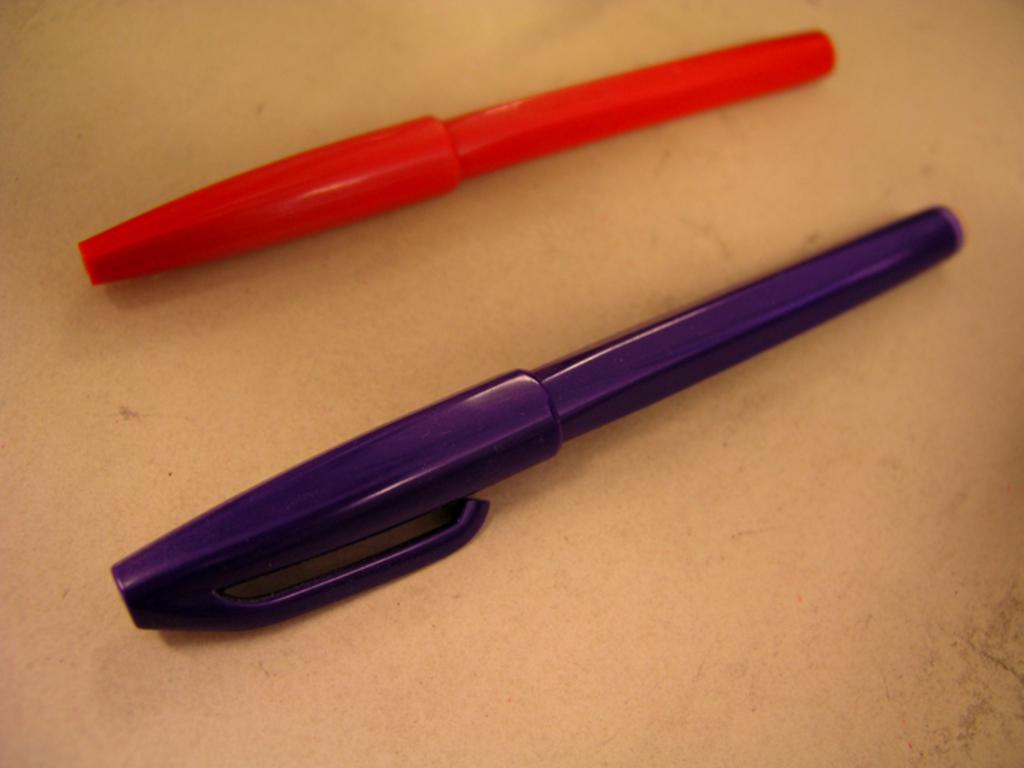How many pens are visible in the image? There are two pens in the image. What colors are the pens? One pen is orange in color, and the other pen is purple in color. What type of stew is being cooked in the image? There is no stew present in the image; it only features two pens. Can you describe the texture of the pens' lips in the image? There are no lips present on the pens in the image, as they are writing instruments and not living beings. 